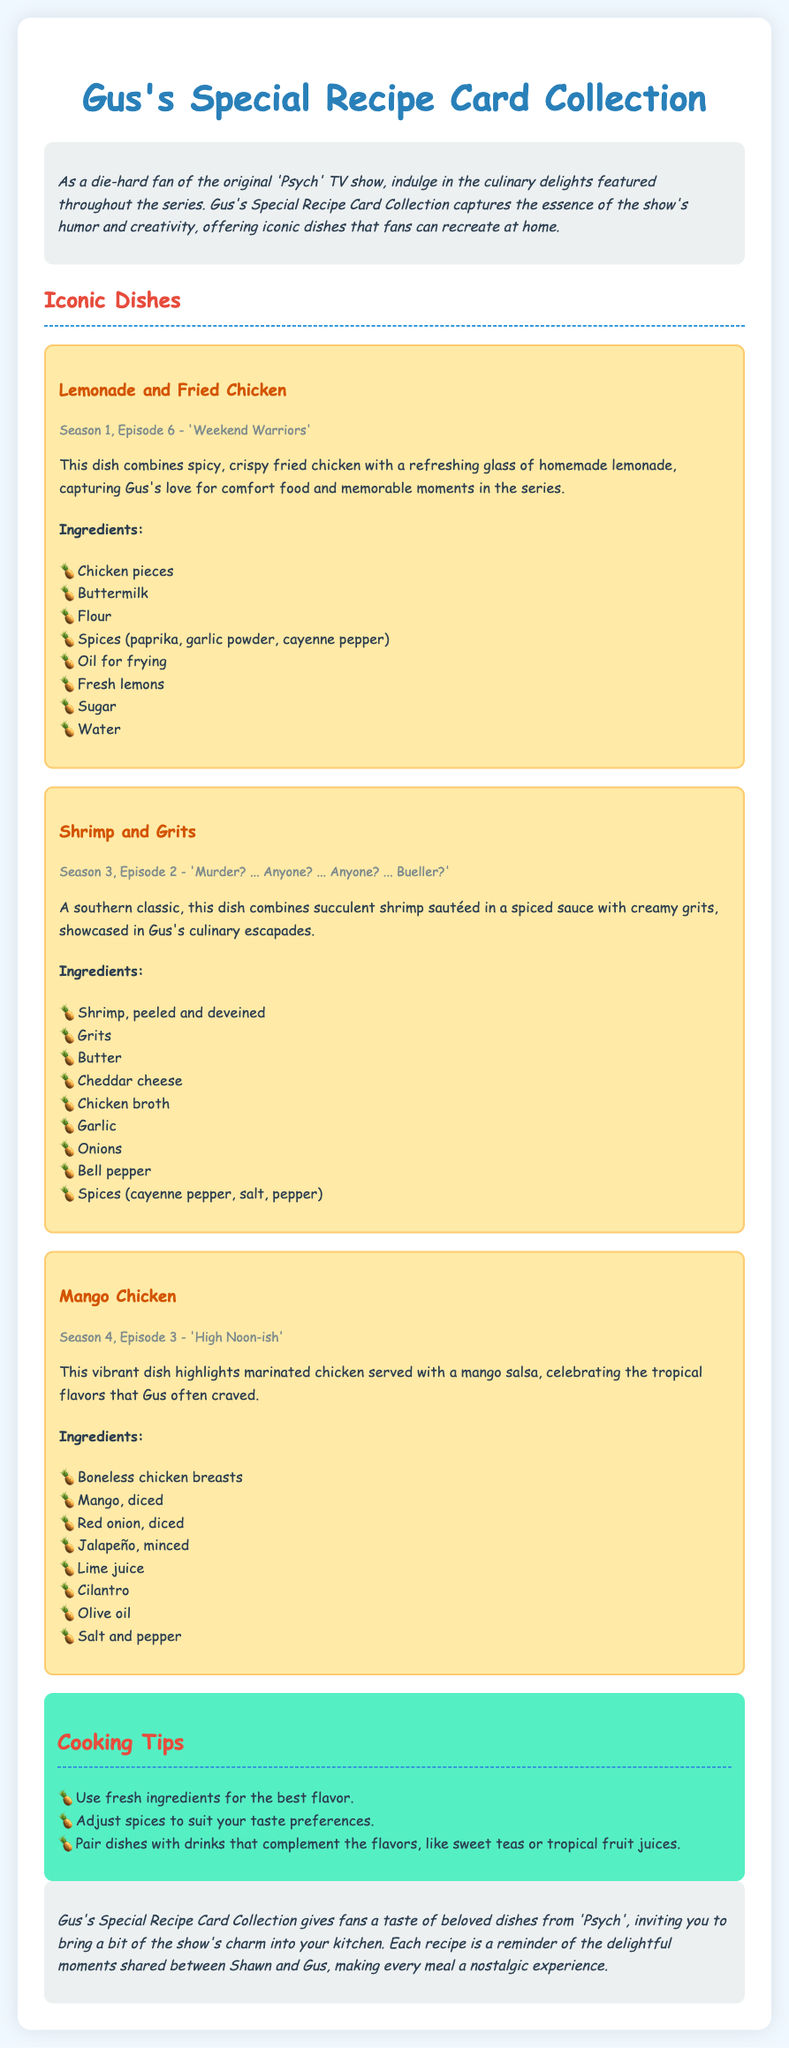What is the title of the collection? The title of the collection is presented at the top of the document.
Answer: Gus's Special Recipe Card Collection How many recipes are featured in the collection? There are a total of three recipes listed in the document.
Answer: Three What is the first recipe in the collection? The first recipe is mentioned in the Recipe Card section.
Answer: Lemonade and Fried Chicken In which episode does the Lemonade and Fried Chicken dish appear? The corresponding episode is specified under the first recipe card.
Answer: Season 1, Episode 6 - 'Weekend Warriors' What is one of the key ingredients for Shrimp and Grits? A key ingredient is listed under the Ingredients section for the Shrimp and Grits dish.
Answer: Shrimp What type of dish is Mango Chicken? The type of dish for Mango Chicken is detailed in its description.
Answer: Vibrant dish What cooking tip is provided in the document? A specific tip can be found in the Tips section of the document.
Answer: Use fresh ingredients for the best flavor What flavors does Gus often crave according to the Mango Chicken description? The flavors referred to are indicated in the description of the specific dish.
Answer: Tropical flavors What does the conclusion suggest about the recipes? The conclusion summarizes the overall sentiment about the recipes in relation to the show.
Answer: Nostalgic experience 